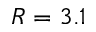<formula> <loc_0><loc_0><loc_500><loc_500>R = 3 . 1</formula> 